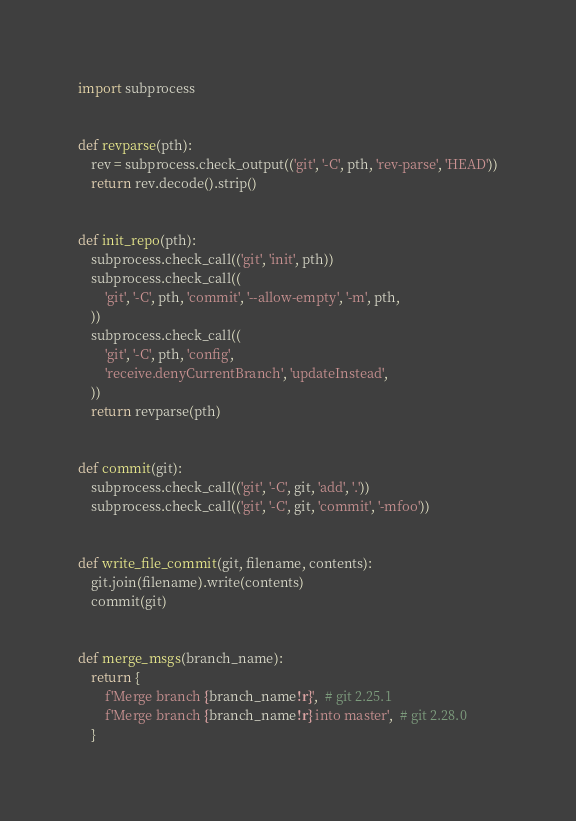Convert code to text. <code><loc_0><loc_0><loc_500><loc_500><_Python_>import subprocess


def revparse(pth):
    rev = subprocess.check_output(('git', '-C', pth, 'rev-parse', 'HEAD'))
    return rev.decode().strip()


def init_repo(pth):
    subprocess.check_call(('git', 'init', pth))
    subprocess.check_call((
        'git', '-C', pth, 'commit', '--allow-empty', '-m', pth,
    ))
    subprocess.check_call((
        'git', '-C', pth, 'config',
        'receive.denyCurrentBranch', 'updateInstead',
    ))
    return revparse(pth)


def commit(git):
    subprocess.check_call(('git', '-C', git, 'add', '.'))
    subprocess.check_call(('git', '-C', git, 'commit', '-mfoo'))


def write_file_commit(git, filename, contents):
    git.join(filename).write(contents)
    commit(git)


def merge_msgs(branch_name):
    return {
        f'Merge branch {branch_name!r}',  # git 2.25.1
        f'Merge branch {branch_name!r} into master',  # git 2.28.0
    }
</code> 